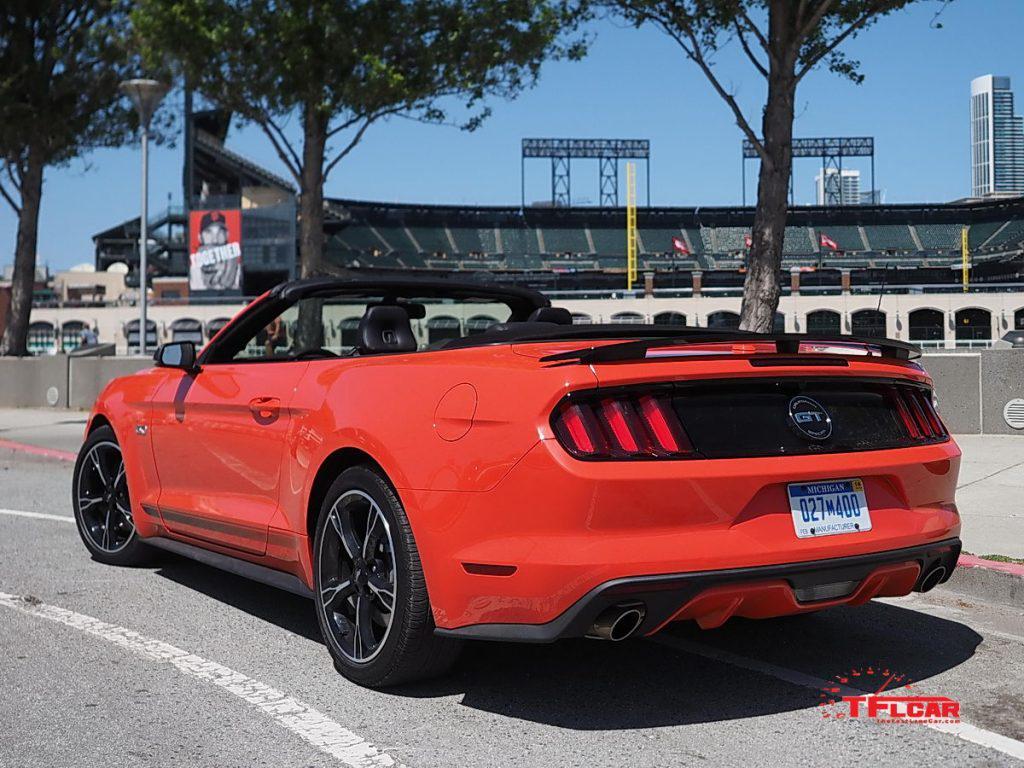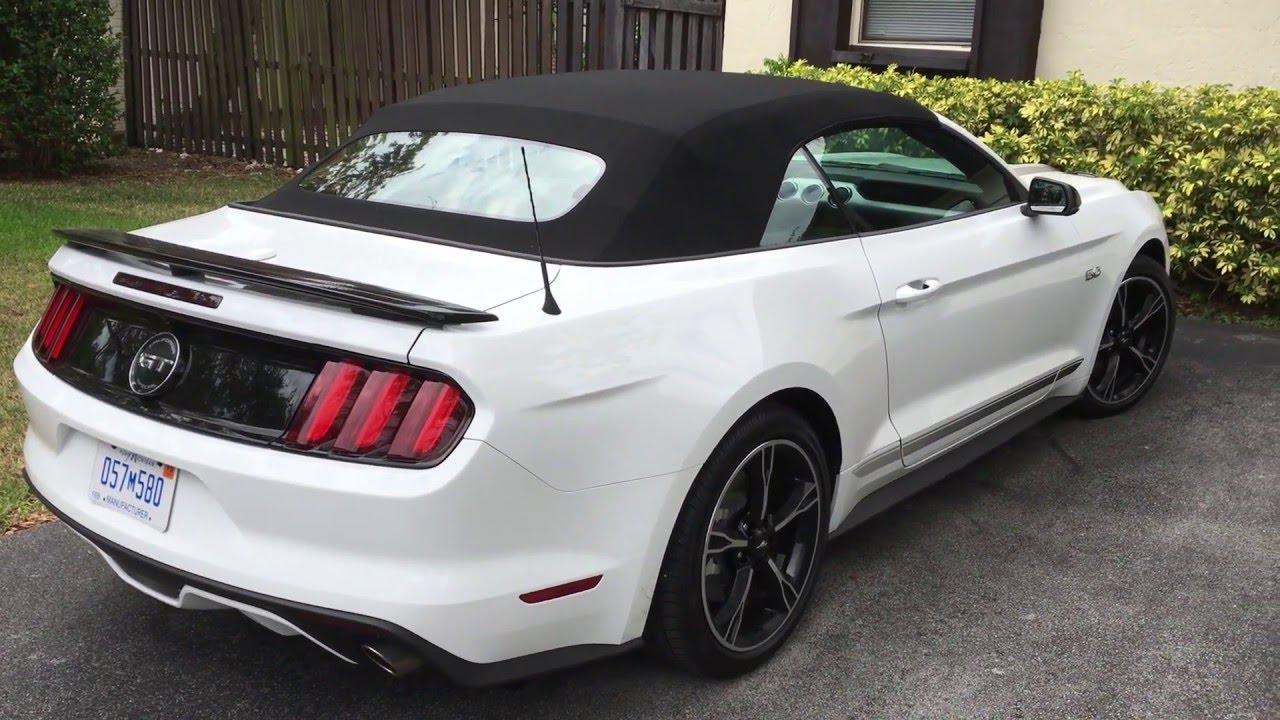The first image is the image on the left, the second image is the image on the right. Analyze the images presented: Is the assertion "A red convertible with the top down is shown in the left image on a paved surface" valid? Answer yes or no. Yes. The first image is the image on the left, the second image is the image on the right. For the images shown, is this caption "A red convertible is displayed at an angle on pavement in the left image, while the right image shows a white convertible." true? Answer yes or no. Yes. 